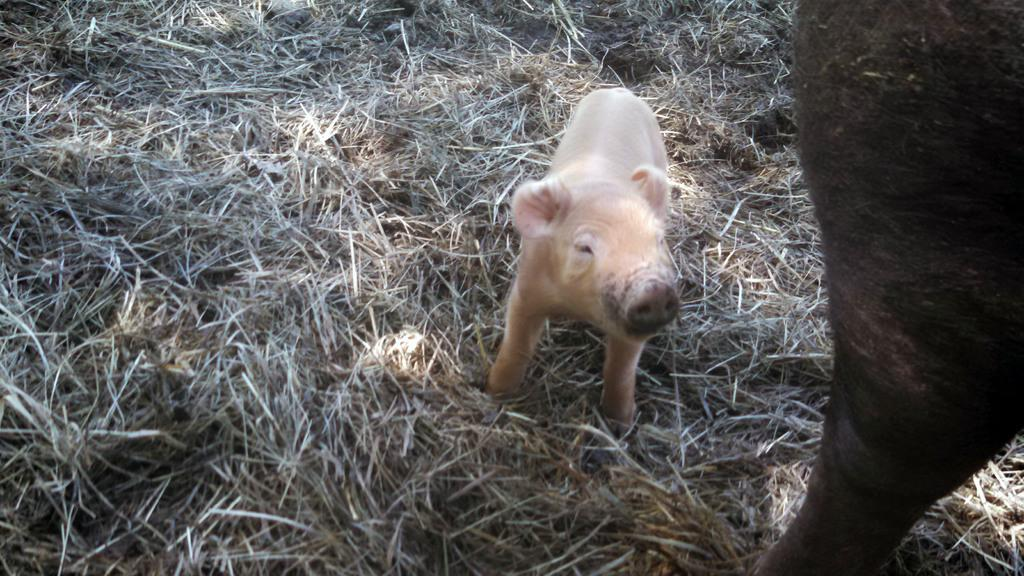What animal can be seen on the ground in the image? There is a pig on the ground in the image. What type of vegetation is present on the ground in the image? There is dry grass on the ground in the image. What part of an animal is visible on the right side of the image? There is a leg of an animal on the right side of the image. What time does the alarm go off in the image? There is no alarm present in the image. What phase is the moon in the image? There is no moon visible in the image. 